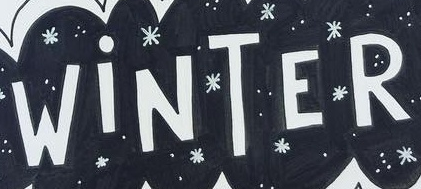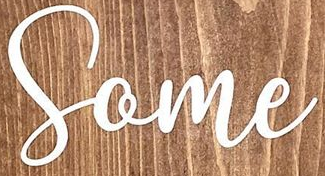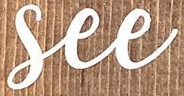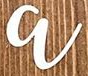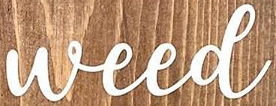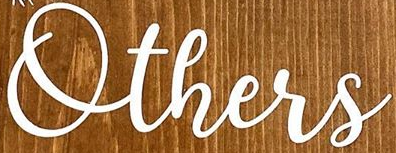What words can you see in these images in sequence, separated by a semicolon? WiNTER; Some; See; a; Weed; Others 